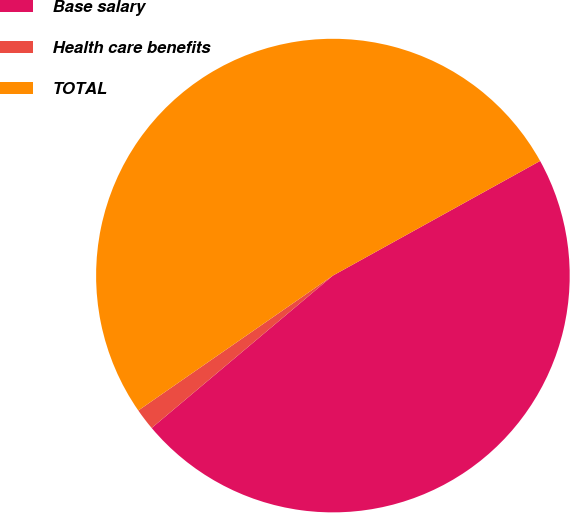<chart> <loc_0><loc_0><loc_500><loc_500><pie_chart><fcel>Base salary<fcel>Health care benefits<fcel>TOTAL<nl><fcel>46.92%<fcel>1.48%<fcel>51.61%<nl></chart> 